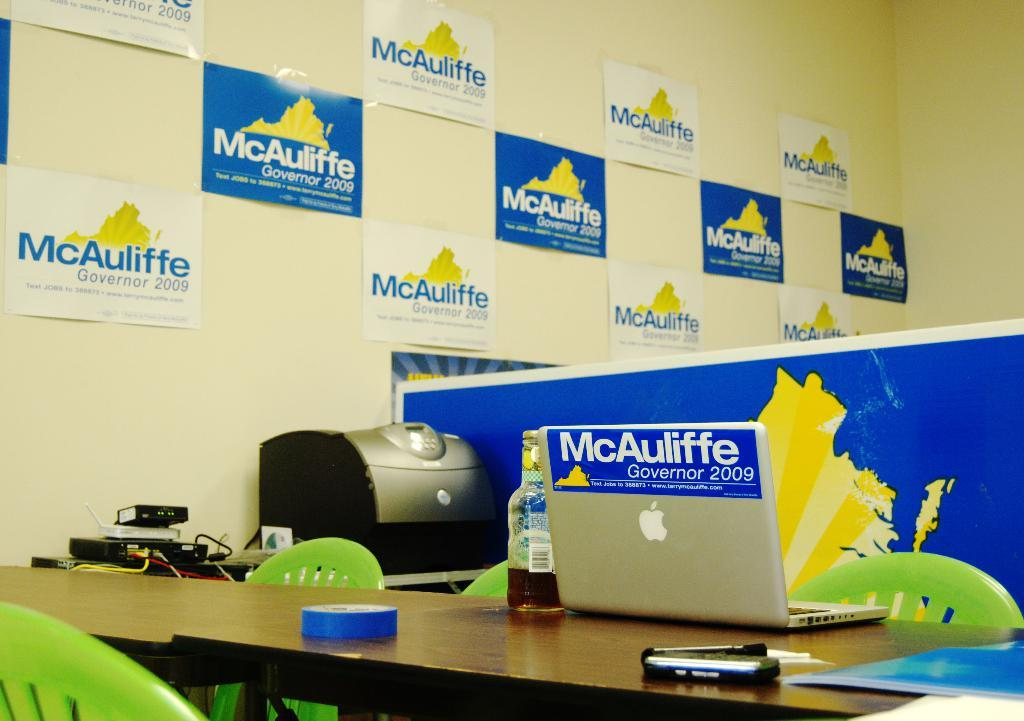<image>
Relay a brief, clear account of the picture shown. an office with a laptop for mcAuliffe for governor 2009 